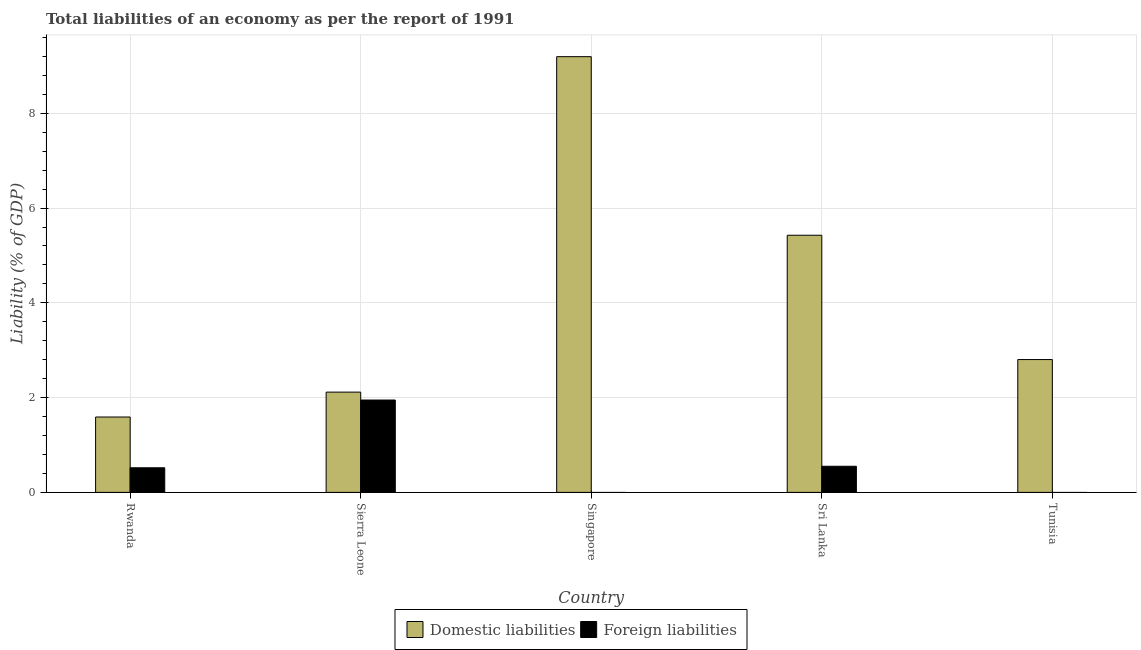How many different coloured bars are there?
Your answer should be very brief. 2. How many bars are there on the 5th tick from the right?
Your response must be concise. 2. What is the label of the 5th group of bars from the left?
Offer a very short reply. Tunisia. What is the incurrence of foreign liabilities in Singapore?
Your answer should be very brief. 0. Across all countries, what is the maximum incurrence of domestic liabilities?
Your answer should be very brief. 9.2. In which country was the incurrence of domestic liabilities maximum?
Provide a succinct answer. Singapore. What is the total incurrence of foreign liabilities in the graph?
Give a very brief answer. 3.02. What is the difference between the incurrence of domestic liabilities in Sierra Leone and that in Tunisia?
Ensure brevity in your answer.  -0.69. What is the difference between the incurrence of domestic liabilities in Sierra Leone and the incurrence of foreign liabilities in Sri Lanka?
Make the answer very short. 1.56. What is the average incurrence of domestic liabilities per country?
Give a very brief answer. 4.23. What is the difference between the incurrence of foreign liabilities and incurrence of domestic liabilities in Sri Lanka?
Keep it short and to the point. -4.88. In how many countries, is the incurrence of foreign liabilities greater than 4 %?
Provide a succinct answer. 0. What is the ratio of the incurrence of domestic liabilities in Singapore to that in Sri Lanka?
Give a very brief answer. 1.69. Is the difference between the incurrence of domestic liabilities in Sierra Leone and Sri Lanka greater than the difference between the incurrence of foreign liabilities in Sierra Leone and Sri Lanka?
Your response must be concise. No. What is the difference between the highest and the second highest incurrence of domestic liabilities?
Ensure brevity in your answer.  3.77. What is the difference between the highest and the lowest incurrence of foreign liabilities?
Offer a very short reply. 1.95. How many bars are there?
Provide a succinct answer. 8. Are all the bars in the graph horizontal?
Offer a very short reply. No. What is the difference between two consecutive major ticks on the Y-axis?
Provide a succinct answer. 2. Are the values on the major ticks of Y-axis written in scientific E-notation?
Your answer should be compact. No. Does the graph contain grids?
Give a very brief answer. Yes. Where does the legend appear in the graph?
Your answer should be compact. Bottom center. What is the title of the graph?
Ensure brevity in your answer.  Total liabilities of an economy as per the report of 1991. What is the label or title of the Y-axis?
Offer a terse response. Liability (% of GDP). What is the Liability (% of GDP) of Domestic liabilities in Rwanda?
Your answer should be compact. 1.59. What is the Liability (% of GDP) of Foreign liabilities in Rwanda?
Keep it short and to the point. 0.52. What is the Liability (% of GDP) in Domestic liabilities in Sierra Leone?
Your response must be concise. 2.12. What is the Liability (% of GDP) in Foreign liabilities in Sierra Leone?
Make the answer very short. 1.95. What is the Liability (% of GDP) of Domestic liabilities in Singapore?
Give a very brief answer. 9.2. What is the Liability (% of GDP) in Foreign liabilities in Singapore?
Ensure brevity in your answer.  0. What is the Liability (% of GDP) in Domestic liabilities in Sri Lanka?
Offer a very short reply. 5.43. What is the Liability (% of GDP) in Foreign liabilities in Sri Lanka?
Your answer should be compact. 0.55. What is the Liability (% of GDP) in Domestic liabilities in Tunisia?
Provide a succinct answer. 2.8. Across all countries, what is the maximum Liability (% of GDP) in Domestic liabilities?
Your answer should be very brief. 9.2. Across all countries, what is the maximum Liability (% of GDP) in Foreign liabilities?
Offer a very short reply. 1.95. Across all countries, what is the minimum Liability (% of GDP) of Domestic liabilities?
Offer a very short reply. 1.59. Across all countries, what is the minimum Liability (% of GDP) in Foreign liabilities?
Provide a succinct answer. 0. What is the total Liability (% of GDP) in Domestic liabilities in the graph?
Offer a very short reply. 21.13. What is the total Liability (% of GDP) in Foreign liabilities in the graph?
Ensure brevity in your answer.  3.02. What is the difference between the Liability (% of GDP) in Domestic liabilities in Rwanda and that in Sierra Leone?
Ensure brevity in your answer.  -0.53. What is the difference between the Liability (% of GDP) of Foreign liabilities in Rwanda and that in Sierra Leone?
Provide a succinct answer. -1.43. What is the difference between the Liability (% of GDP) in Domestic liabilities in Rwanda and that in Singapore?
Ensure brevity in your answer.  -7.61. What is the difference between the Liability (% of GDP) of Domestic liabilities in Rwanda and that in Sri Lanka?
Keep it short and to the point. -3.84. What is the difference between the Liability (% of GDP) of Foreign liabilities in Rwanda and that in Sri Lanka?
Your answer should be compact. -0.03. What is the difference between the Liability (% of GDP) of Domestic liabilities in Rwanda and that in Tunisia?
Provide a succinct answer. -1.21. What is the difference between the Liability (% of GDP) in Domestic liabilities in Sierra Leone and that in Singapore?
Keep it short and to the point. -7.08. What is the difference between the Liability (% of GDP) in Domestic liabilities in Sierra Leone and that in Sri Lanka?
Your answer should be very brief. -3.31. What is the difference between the Liability (% of GDP) of Foreign liabilities in Sierra Leone and that in Sri Lanka?
Give a very brief answer. 1.4. What is the difference between the Liability (% of GDP) of Domestic liabilities in Sierra Leone and that in Tunisia?
Provide a short and direct response. -0.69. What is the difference between the Liability (% of GDP) in Domestic liabilities in Singapore and that in Sri Lanka?
Give a very brief answer. 3.77. What is the difference between the Liability (% of GDP) of Domestic liabilities in Singapore and that in Tunisia?
Give a very brief answer. 6.39. What is the difference between the Liability (% of GDP) of Domestic liabilities in Sri Lanka and that in Tunisia?
Give a very brief answer. 2.62. What is the difference between the Liability (% of GDP) of Domestic liabilities in Rwanda and the Liability (% of GDP) of Foreign liabilities in Sierra Leone?
Offer a very short reply. -0.36. What is the difference between the Liability (% of GDP) in Domestic liabilities in Rwanda and the Liability (% of GDP) in Foreign liabilities in Sri Lanka?
Keep it short and to the point. 1.04. What is the difference between the Liability (% of GDP) in Domestic liabilities in Sierra Leone and the Liability (% of GDP) in Foreign liabilities in Sri Lanka?
Ensure brevity in your answer.  1.56. What is the difference between the Liability (% of GDP) in Domestic liabilities in Singapore and the Liability (% of GDP) in Foreign liabilities in Sri Lanka?
Make the answer very short. 8.64. What is the average Liability (% of GDP) of Domestic liabilities per country?
Provide a succinct answer. 4.23. What is the average Liability (% of GDP) of Foreign liabilities per country?
Your response must be concise. 0.6. What is the difference between the Liability (% of GDP) of Domestic liabilities and Liability (% of GDP) of Foreign liabilities in Rwanda?
Provide a succinct answer. 1.07. What is the difference between the Liability (% of GDP) in Domestic liabilities and Liability (% of GDP) in Foreign liabilities in Sierra Leone?
Make the answer very short. 0.17. What is the difference between the Liability (% of GDP) in Domestic liabilities and Liability (% of GDP) in Foreign liabilities in Sri Lanka?
Give a very brief answer. 4.88. What is the ratio of the Liability (% of GDP) of Domestic liabilities in Rwanda to that in Sierra Leone?
Your response must be concise. 0.75. What is the ratio of the Liability (% of GDP) of Foreign liabilities in Rwanda to that in Sierra Leone?
Make the answer very short. 0.27. What is the ratio of the Liability (% of GDP) in Domestic liabilities in Rwanda to that in Singapore?
Offer a terse response. 0.17. What is the ratio of the Liability (% of GDP) of Domestic liabilities in Rwanda to that in Sri Lanka?
Offer a terse response. 0.29. What is the ratio of the Liability (% of GDP) in Foreign liabilities in Rwanda to that in Sri Lanka?
Make the answer very short. 0.94. What is the ratio of the Liability (% of GDP) of Domestic liabilities in Rwanda to that in Tunisia?
Ensure brevity in your answer.  0.57. What is the ratio of the Liability (% of GDP) in Domestic liabilities in Sierra Leone to that in Singapore?
Provide a short and direct response. 0.23. What is the ratio of the Liability (% of GDP) in Domestic liabilities in Sierra Leone to that in Sri Lanka?
Ensure brevity in your answer.  0.39. What is the ratio of the Liability (% of GDP) in Foreign liabilities in Sierra Leone to that in Sri Lanka?
Offer a terse response. 3.54. What is the ratio of the Liability (% of GDP) in Domestic liabilities in Sierra Leone to that in Tunisia?
Your response must be concise. 0.75. What is the ratio of the Liability (% of GDP) of Domestic liabilities in Singapore to that in Sri Lanka?
Provide a succinct answer. 1.69. What is the ratio of the Liability (% of GDP) in Domestic liabilities in Singapore to that in Tunisia?
Provide a succinct answer. 3.28. What is the ratio of the Liability (% of GDP) in Domestic liabilities in Sri Lanka to that in Tunisia?
Make the answer very short. 1.94. What is the difference between the highest and the second highest Liability (% of GDP) in Domestic liabilities?
Provide a short and direct response. 3.77. What is the difference between the highest and the second highest Liability (% of GDP) in Foreign liabilities?
Offer a terse response. 1.4. What is the difference between the highest and the lowest Liability (% of GDP) of Domestic liabilities?
Make the answer very short. 7.61. What is the difference between the highest and the lowest Liability (% of GDP) in Foreign liabilities?
Provide a succinct answer. 1.95. 